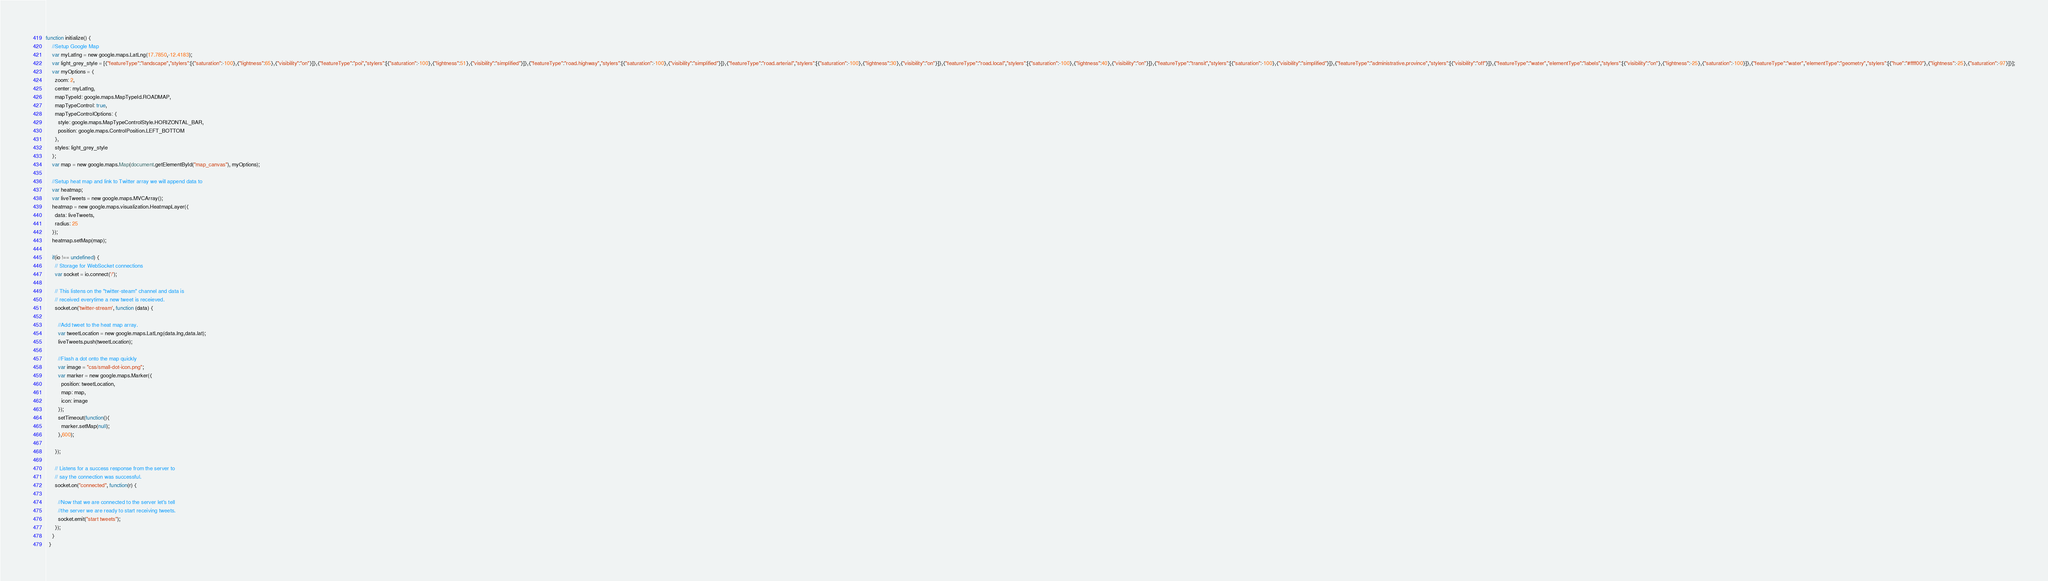<code> <loc_0><loc_0><loc_500><loc_500><_JavaScript_>function initialize() {
    //Setup Google Map
    var myLatlng = new google.maps.LatLng(17.7850,-12.4183);
    var light_grey_style = [{"featureType":"landscape","stylers":[{"saturation":-100},{"lightness":65},{"visibility":"on"}]},{"featureType":"poi","stylers":[{"saturation":-100},{"lightness":51},{"visibility":"simplified"}]},{"featureType":"road.highway","stylers":[{"saturation":-100},{"visibility":"simplified"}]},{"featureType":"road.arterial","stylers":[{"saturation":-100},{"lightness":30},{"visibility":"on"}]},{"featureType":"road.local","stylers":[{"saturation":-100},{"lightness":40},{"visibility":"on"}]},{"featureType":"transit","stylers":[{"saturation":-100},{"visibility":"simplified"}]},{"featureType":"administrative.province","stylers":[{"visibility":"off"}]},{"featureType":"water","elementType":"labels","stylers":[{"visibility":"on"},{"lightness":-25},{"saturation":-100}]},{"featureType":"water","elementType":"geometry","stylers":[{"hue":"#ffff00"},{"lightness":-25},{"saturation":-97}]}];
    var myOptions = {
      zoom: 2,
      center: myLatlng,
      mapTypeId: google.maps.MapTypeId.ROADMAP,
      mapTypeControl: true,
      mapTypeControlOptions: {
        style: google.maps.MapTypeControlStyle.HORIZONTAL_BAR,
        position: google.maps.ControlPosition.LEFT_BOTTOM
      },
      styles: light_grey_style
    };
    var map = new google.maps.Map(document.getElementById("map_canvas"), myOptions);
    
    //Setup heat map and link to Twitter array we will append data to
    var heatmap;
    var liveTweets = new google.maps.MVCArray();
    heatmap = new google.maps.visualization.HeatmapLayer({
      data: liveTweets,
      radius: 25
    });
    heatmap.setMap(map);
  
    if(io !== undefined) {
      // Storage for WebSocket connections
      var socket = io.connect('/');
  
      // This listens on the "twitter-steam" channel and data is 
      // received everytime a new tweet is receieved.
      socket.on('twitter-stream', function (data) {
  
        //Add tweet to the heat map array.
        var tweetLocation = new google.maps.LatLng(data.lng,data.lat);
        liveTweets.push(tweetLocation);
  
        //Flash a dot onto the map quickly
        var image = "css/small-dot-icon.png";
        var marker = new google.maps.Marker({
          position: tweetLocation,
          map: map,
          icon: image
        });
        setTimeout(function(){
          marker.setMap(null);
        },600);
  
      });
  
      // Listens for a success response from the server to 
      // say the connection was successful.
      socket.on("connected", function(r) {
  
        //Now that we are connected to the server let's tell 
        //the server we are ready to start receiving tweets.
        socket.emit("start tweets");
      });
    }
  }</code> 